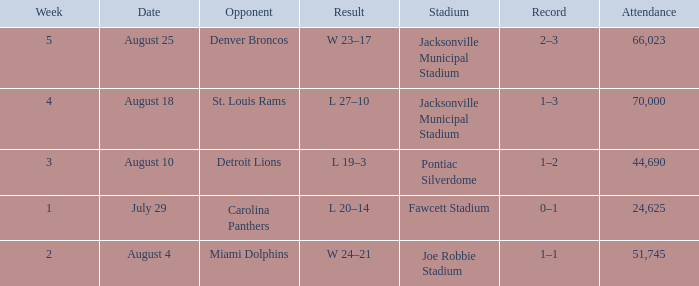WHEN has a Result of w 23–17? August 25. 